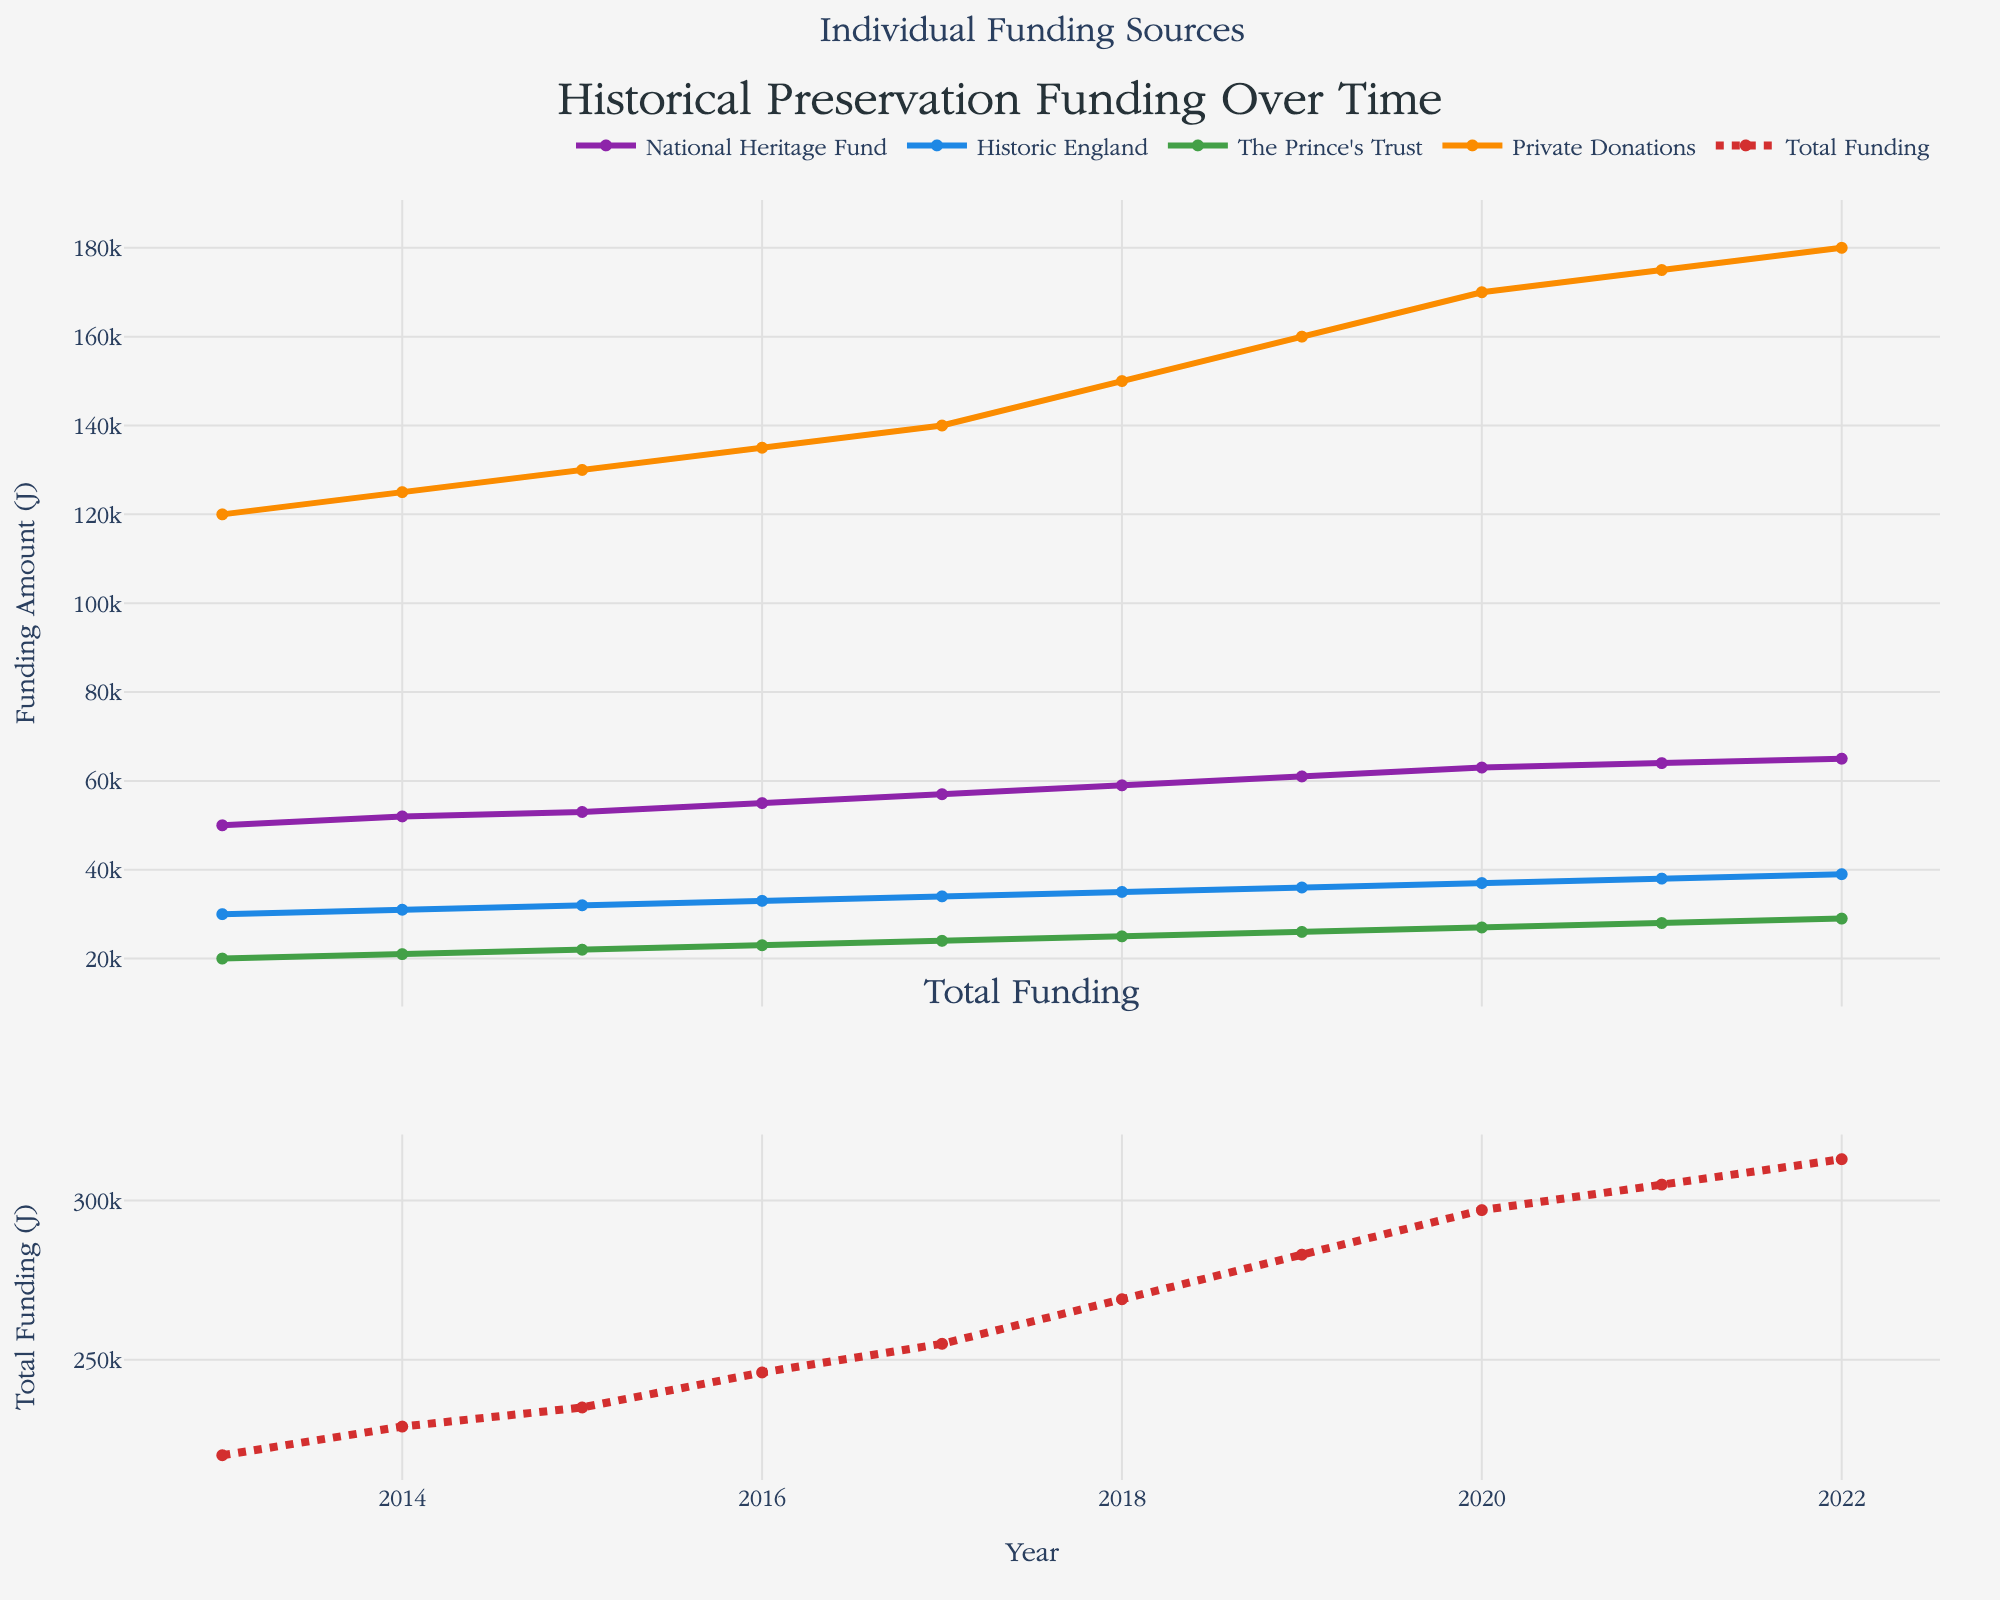What is the title of the plot? The title is located at the top of the figure. It reads "Historical Preservation Funding Over Time".
Answer: Historical Preservation Funding Over Time Which funding source had the highest amount in 2022? By observing the plot for 2022, we can see that Private Donations have the highest amount in that year.
Answer: Private Donations What is the range of years shown in the plot? The x-axis of the plot labels the years from 2013 to 2022.
Answer: 2013 to 2022 How does the National Heritage Fund's amount change from 2013 to 2022? The National Heritage Fund shows a gradual increase from 50,000 in 2013 to 65,000 in 2022.
Answer: Increased from 50,000 to 65,000 Which year saw the greatest total funding? By looking at the 'Total Funding' line in the second subplot, 2022 shows the highest total funding amount, approximately 313,000.
Answer: 2022 By how much did Private Donations increase between 2013 and 2022? Private Donations in 2013 were 120,000, and in 2022 they were 180,000. The difference is 180,000 - 120,000 = 60,000.
Answer: 60,000 Which funding source showed the least variability over the years? By examining the traces for each funding source, the Historic England funding line appears to be the most stable with gradual increases each year.
Answer: Historic England How did the total funding change between 2013 and 2022? Observing the 'Total Funding' line in the second subplot, the total funding increased from 220,000 in 2013 to 313,000 in 2022.
Answer: Increased from 220,000 to 313,000 Which funding source grew the fastest from 2013 to 2017? We identify the steepest slope from 2013 to 2017 among the funding sources. The 'Prince's Trust' shows the fastest growth in this period.
Answer: The Prince's Trust 